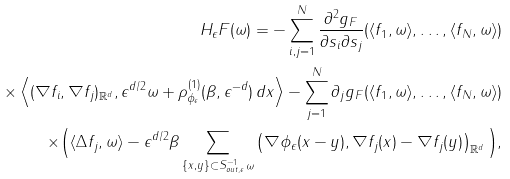Convert formula to latex. <formula><loc_0><loc_0><loc_500><loc_500>H _ { \epsilon } F ( \omega ) = - \sum _ { i , j = 1 } ^ { N } \frac { \partial ^ { 2 } g _ { F } } { \partial s _ { i } \partial s _ { j } } ( \langle f _ { 1 } , \omega \rangle , \dots , \langle f _ { N } , \omega \rangle ) \\ \times \left \langle ( \nabla f _ { i } , \nabla f _ { j } ) _ { { \mathbb { R } } ^ { d } } , \epsilon ^ { d / 2 } \omega + \rho ^ { ( 1 ) } _ { \phi _ { \epsilon } } ( \beta , \epsilon ^ { - d } ) \, d x \right \rangle - \sum _ { j = 1 } ^ { N } \partial _ { j } g _ { F } ( \langle f _ { 1 } , \omega \rangle , \dots , \langle f _ { N } , \omega \rangle ) \\ \times \Big { ( } \langle \Delta f _ { j } , \omega \rangle - \epsilon ^ { d / 2 } \beta \sum _ { \{ x , y \} \subset S ^ { - 1 } _ { o u t , \epsilon } \omega } \left ( \nabla \phi _ { \epsilon } ( x - y ) , \nabla f _ { j } ( x ) - \nabla f _ { j } ( y ) \right ) _ { { \mathbb { R } } ^ { d } } \Big { ) } ,</formula> 